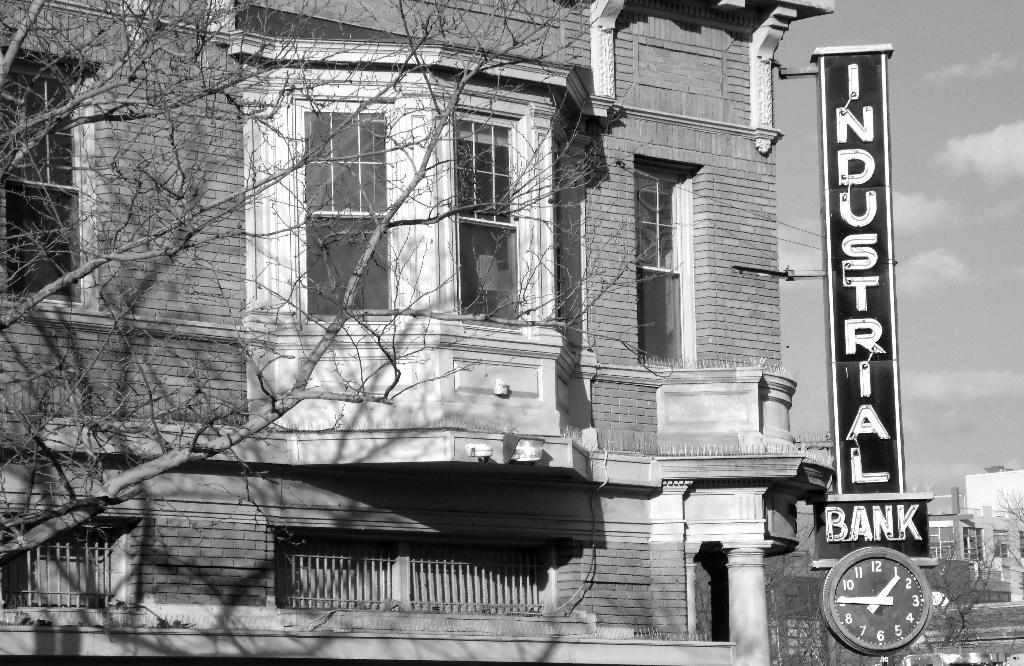Provide a one-sentence caption for the provided image. An Industrial Bank sign and clock are on the corner of a building. 